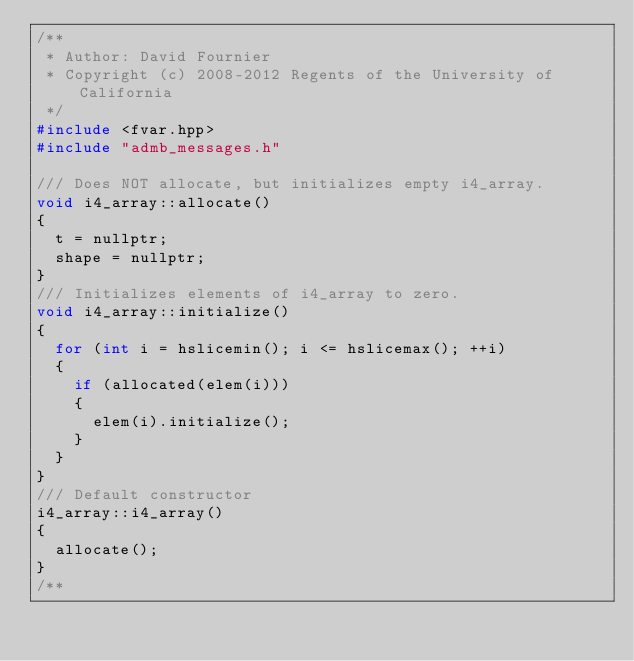<code> <loc_0><loc_0><loc_500><loc_500><_C++_>/**
 * Author: David Fournier
 * Copyright (c) 2008-2012 Regents of the University of California
 */
#include <fvar.hpp>
#include "admb_messages.h"

/// Does NOT allocate, but initializes empty i4_array.
void i4_array::allocate()
{
  t = nullptr;
  shape = nullptr;
}
/// Initializes elements of i4_array to zero.
void i4_array::initialize()
{
  for (int i = hslicemin(); i <= hslicemax(); ++i)
  {
    if (allocated(elem(i)))
    {
      elem(i).initialize();
    }
  }
}
/// Default constructor
i4_array::i4_array()
{
  allocate();
}
/**</code> 